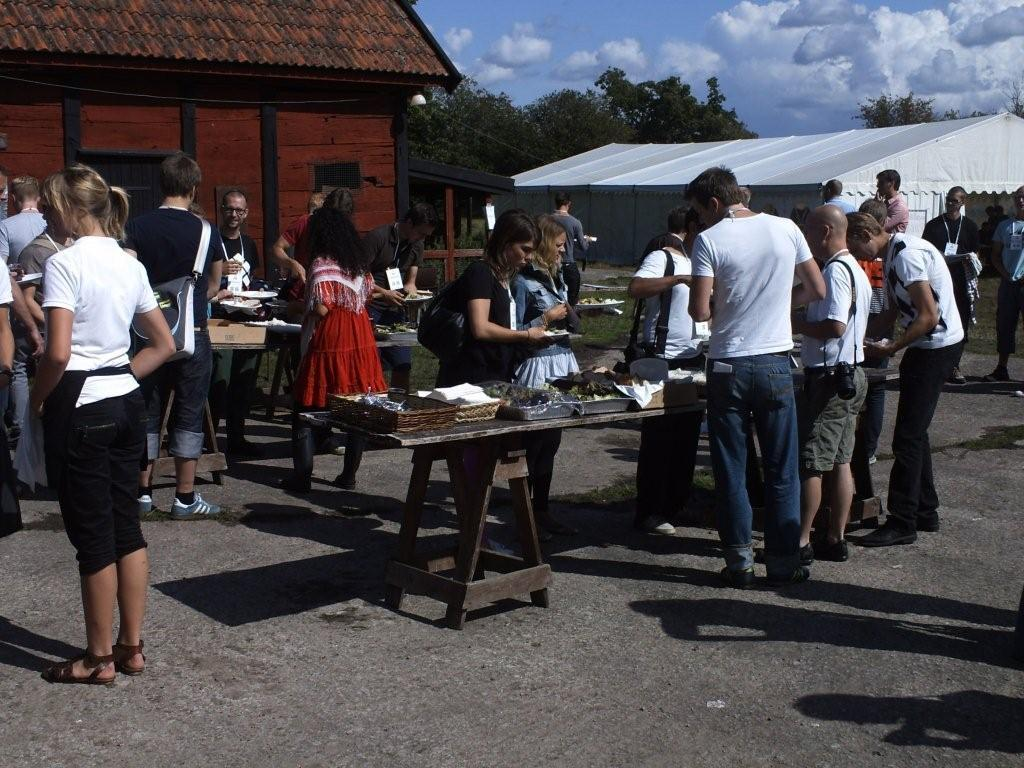What is happening in the image? There are people standing in the image. What can be seen in the distance behind the people? There are buildings, trees, and the sky visible in the background of the image. What type of milk is being poured into the box in the image? There is no box or milk present in the image. How many times does the person fold their arms in the image? There is no indication of anyone folding their arms in the image. 